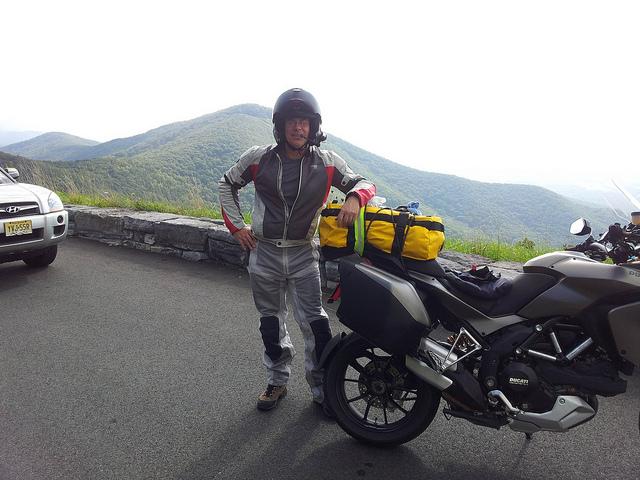What is the man leaning on?
Give a very brief answer. Motorcycle. What color is the man's bag?
Quick response, please. Yellow. Is the man smiling?
Give a very brief answer. Yes. 